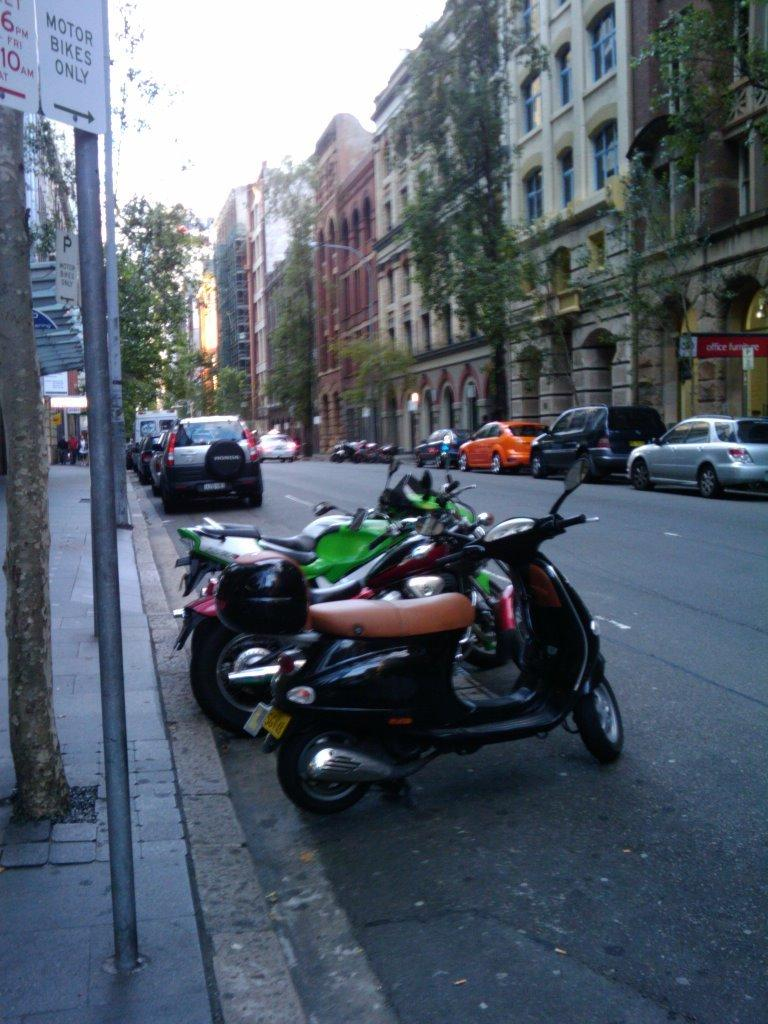What type of vehicles can be seen on the road in the image? There are bikes and cars on the road in the image. What structures are present in the image? There are poles, boards, trees, lights, and buildings in the image. What can be seen in the background of the image? The sky is visible in the background of the image. How many rabbits are pushing the cars in the image? There are no rabbits present in the image, and they are not pushing any cars. What does the image need to be considered complete? The image is already complete as it is, and no additional elements are needed. 